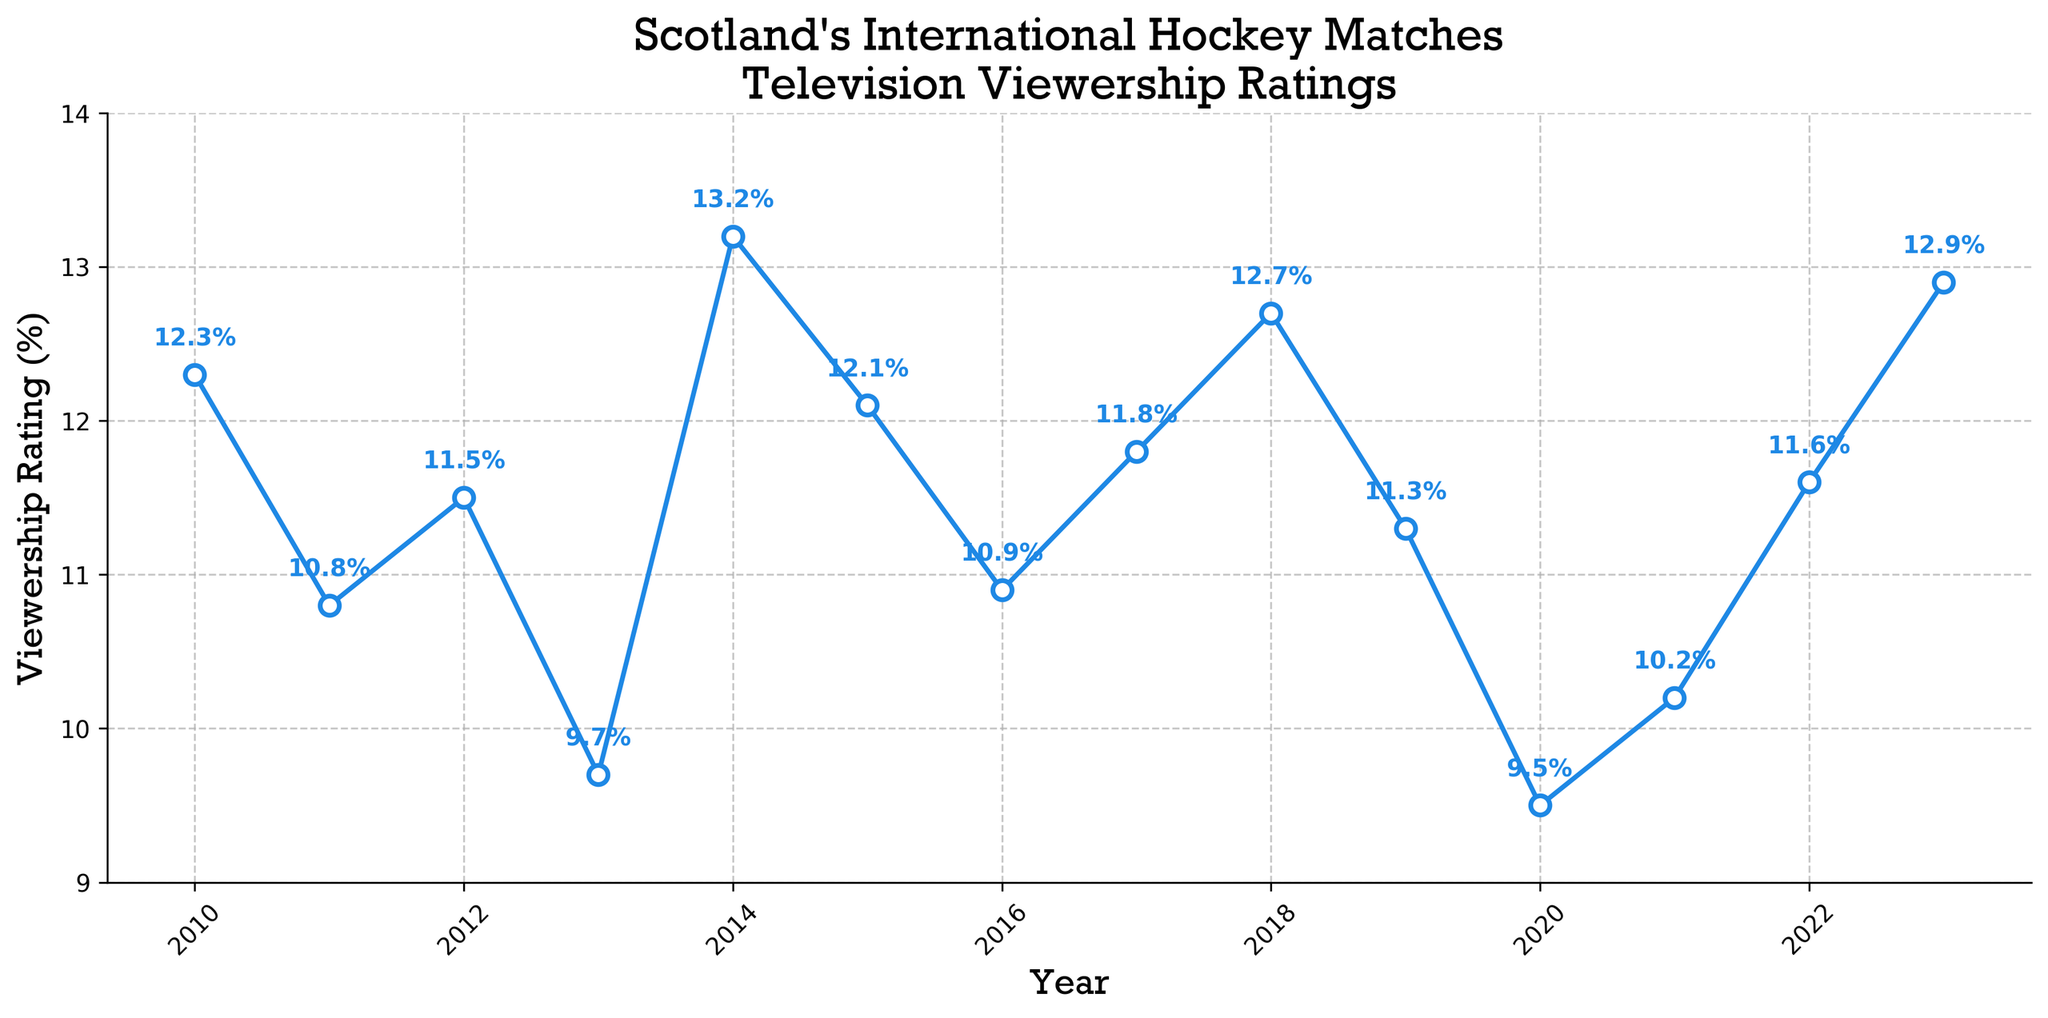How does the viewership rating in 2023 compare to 2020? To compare the viewership rating in 2023 to 2020, find the data points for both years and compare them directly. The viewership rating in 2023 is 12.9%, and in 2020 it's 9.5%. Therefore, the rating in 2023 is higher.
Answer: 12.9% is higher than 9.5% What's the average viewership rating from 2010 to 2015? Sum the viewership ratings from 2010 to 2015 and divide by the number of years. The ratings are 12.3%, 10.8%, 11.5%, 9.7%, 13.2%, and 12.1%. The sum is 69.6%, and there are 6 entries. So, the average is 69.6% / 6.
Answer: 11.6% How much did the viewership increase between 2021 and 2023? Subtract the viewership rating in 2021 from that in 2023. The rating in 2021 is 10.2%, and in 2023 it is 12.9%. The increase is 12.9% - 10.2%.
Answer: 2.7% What is the median viewership rating over the years? List all the viewership ratings in ascending order and find the middle value. Arranged values: 9.5, 9.7, 10.2, 10.8, 10.9, 11.3, 11.5, 11.6, 11.8, 12.1, 12.3, 12.7, 12.9, 13.2. The median is the average of 7th and 8th values: (11.5 + 11.6) / 2.
Answer: 11.55% How many times did the viewership rating drop below 10%? Count the number of data points where the rating is below 10%. The ratings below 10% are 9.7% (2013) and 9.5% (2020).
Answer: 2 times Which year had the highest viewership rating? Look for the highest point on the line chart, which corresponds to the highest viewership rating. The peak rating is in 2014 with 13.2%.
Answer: 2014 Between which two consecutive years did the viewership rating drop the most? Calculate the differences in viewership ratings between each pair of consecutive years and identify the maximum decrease. The largest drop is from 2019 (11.3%) to 2020 (9.5%), a decrease of 1.8%.
Answer: 2019 to 2020 Is the overall trend of viewership ratings from 2010 to 2023 increasing, decreasing, or stable? Examine the general direction of the line plot from 2010 to 2023. Though there are fluctuations, the trend generally shows solidity because the start (12.3% in 2010) and end (12.9% in 2023) are relatively close.
Answer: Stable Are there more increases or decreases in the viewership ratings from year to year? Count the number of increases and decreases between consecutive years. Increases (2012, 2014, 2015, 2017, 2018, 2020, 2022, 2023) and decreases (2011, 2013, 2016, 2019, 2021). There are more increases.
Answer: More increases 